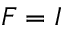Convert formula to latex. <formula><loc_0><loc_0><loc_500><loc_500>F = I</formula> 